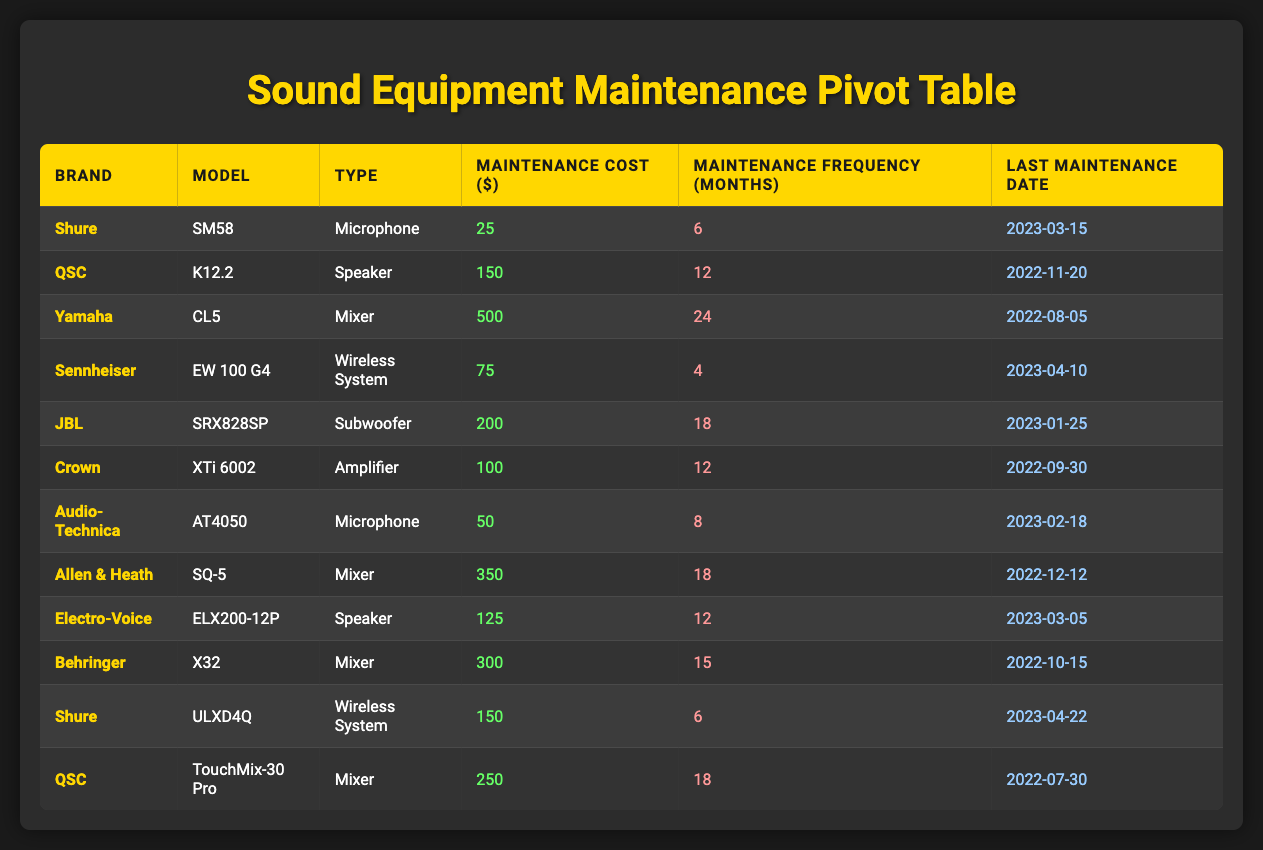What is the maintenance cost of the Shure SM58 microphone? The table lists the Shure SM58 under the brand "Shure" with a corresponding maintenance cost of 25 dollars.
Answer: 25 Which sound equipment has the highest maintenance frequency? By reviewing the maintenance frequencies for all equipment, Yamaha's CL5 mixer has the highest frequency at 24 months.
Answer: 24 How many months does the Sennheiser EW 100 G4 require for maintenance? Looking at the table, the maintenance frequency for Sennheiser EW 100 G4 is listed as 4 months.
Answer: 4 What is the total maintenance cost for QSC equipment? The QSC equipment includes K12.2 (150) and TouchMix-30 Pro (250). Adding these, 150 + 250 equals 400 dollars.
Answer: 400 Is the last maintenance date for the Shure ULXD4Q after April 2023? The last maintenance date for Shure ULXD4Q is April 22, 2023, which is indeed after April 2023.
Answer: Yes What is the average maintenance cost for all microphones? The microphones are Shure SM58 (25), Audio-Technica AT4050 (50), and Shure ULXD4Q (150). Their total is 25 + 50 + 150 = 225 and dividing by 3 gives an average of 75.
Answer: 75 Which brand has equipment with a maintenance cost greater than 150 dollars? The brands with equipment above 150 dollars are Yamaha (500), JBL (200), Allen & Heath (350), and Behringer (300), which shows multiple brands have high maintenance costs.
Answer: Yes How many sound equipment types require maintenance every 12 months? Looking at the table, three types require maintenance every 12 months: QSC K12.2, Crown XTi 6002, and Electro-Voice ELX200-12P.
Answer: 3 If I want to find the most costly equipment for maintenance, which model should I choose? Reviewing the maintenance cost column, the Yamaha CL5 (500) has the highest maintenance cost among all equipment.
Answer: Yamaha CL5 